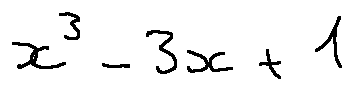<formula> <loc_0><loc_0><loc_500><loc_500>x ^ { 3 } - 3 x + 1</formula> 